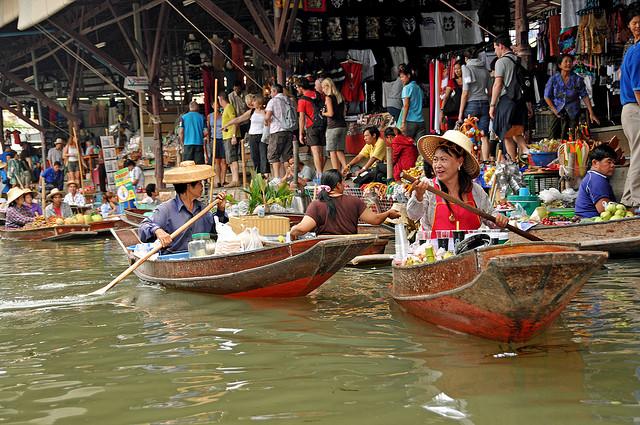What is in the boater's hands?
Give a very brief answer. Oar. Are there many tourists walking around?
Give a very brief answer. Yes. Are the boaters wearing hats?
Give a very brief answer. Yes. 